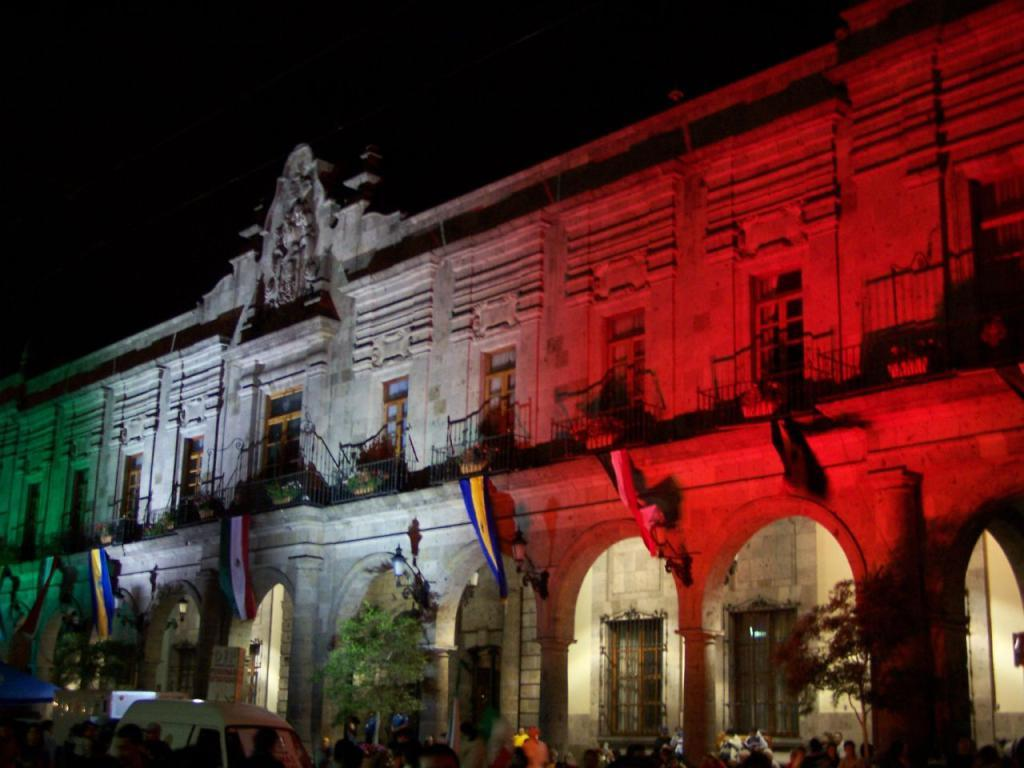What structure is the main focus of the image? There is a building in the image. Are there any people present in the image? Yes, there are people standing near the building. What else can be seen in the image besides the building and people? There is a car and trees visible in the image. What decorations are on the building? There are flags hanging on the building. How is the building illuminated? The building has color lighting. Can you hear the whistle of the birds in the image? There are no birds or whistling sounds mentioned in the image, so it cannot be determined if there is a whistle present. 